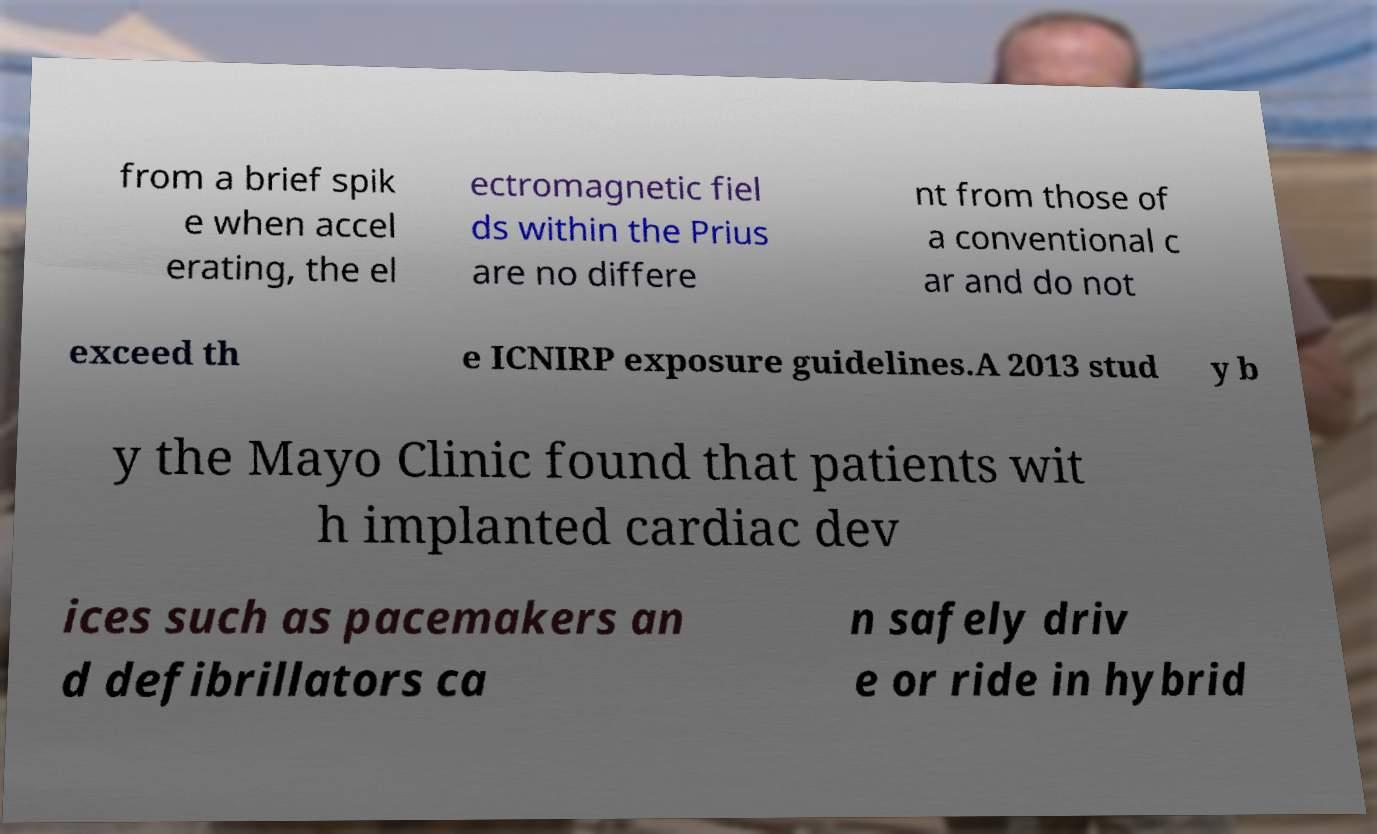Could you assist in decoding the text presented in this image and type it out clearly? from a brief spik e when accel erating, the el ectromagnetic fiel ds within the Prius are no differe nt from those of a conventional c ar and do not exceed th e ICNIRP exposure guidelines.A 2013 stud y b y the Mayo Clinic found that patients wit h implanted cardiac dev ices such as pacemakers an d defibrillators ca n safely driv e or ride in hybrid 